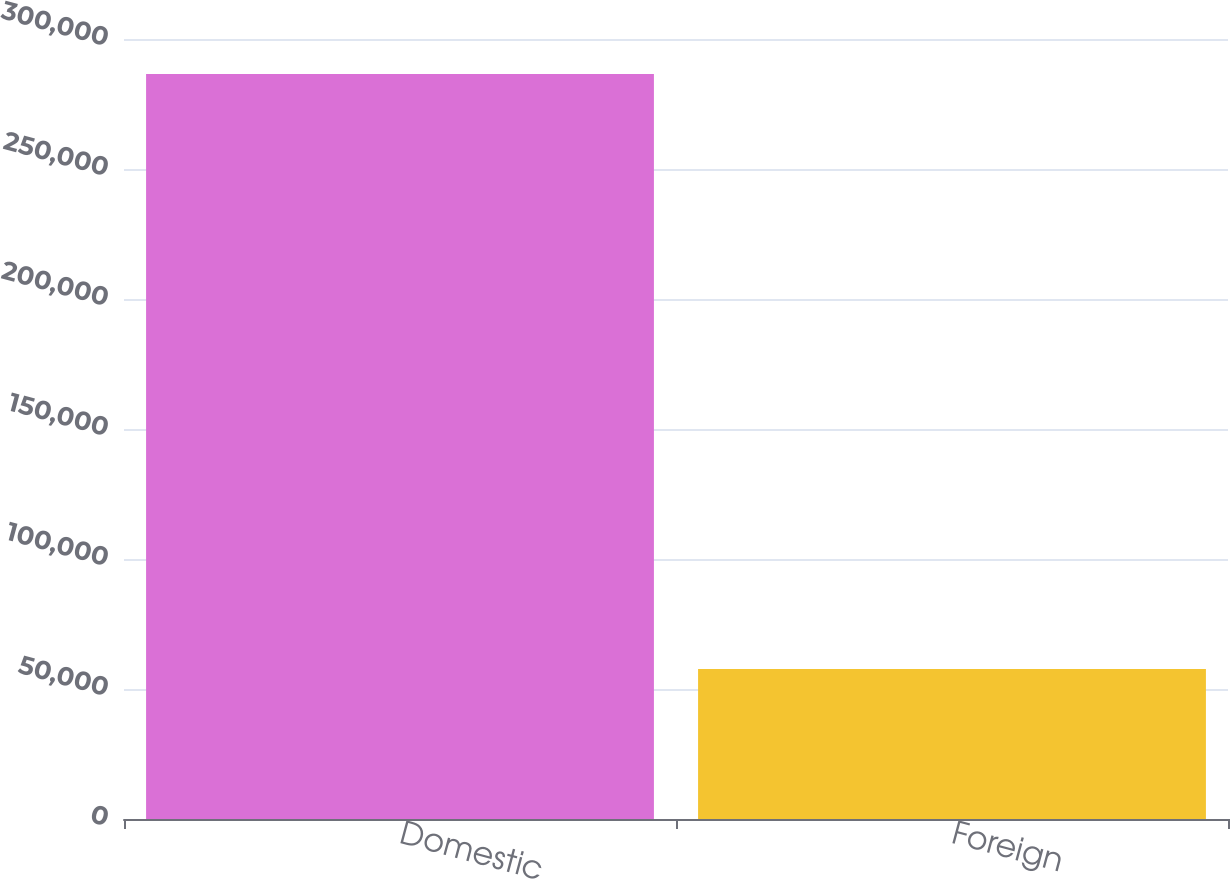<chart> <loc_0><loc_0><loc_500><loc_500><bar_chart><fcel>Domestic<fcel>Foreign<nl><fcel>286537<fcel>57708<nl></chart> 